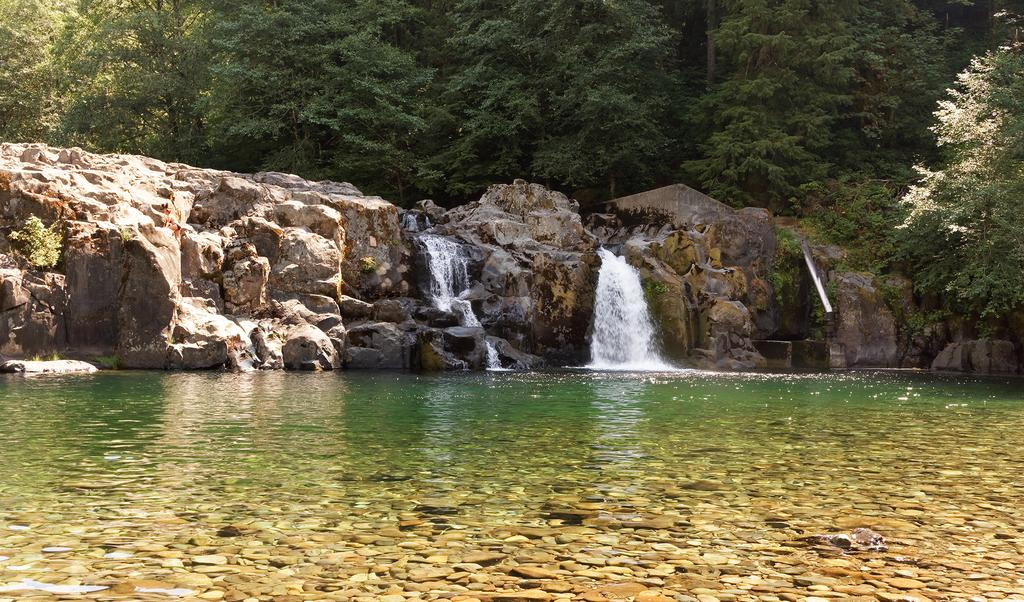What type of natural feature is present in the image? There is a river in the image. What other water feature can be seen in the image? There is a waterfall in the image. What type of geological formation is visible in the image? There are rocks in the image. What type of vegetation is present in the image? There are trees in the image. How many shoes can be seen floating in the river in the image? There are no shoes present in the image; it features a river, waterfall, rocks, and trees. What type of insects can be seen crawling on the rocks in the image? There are no insects, such as ants, present in the image; it only features a river, waterfall, rocks, and trees. 